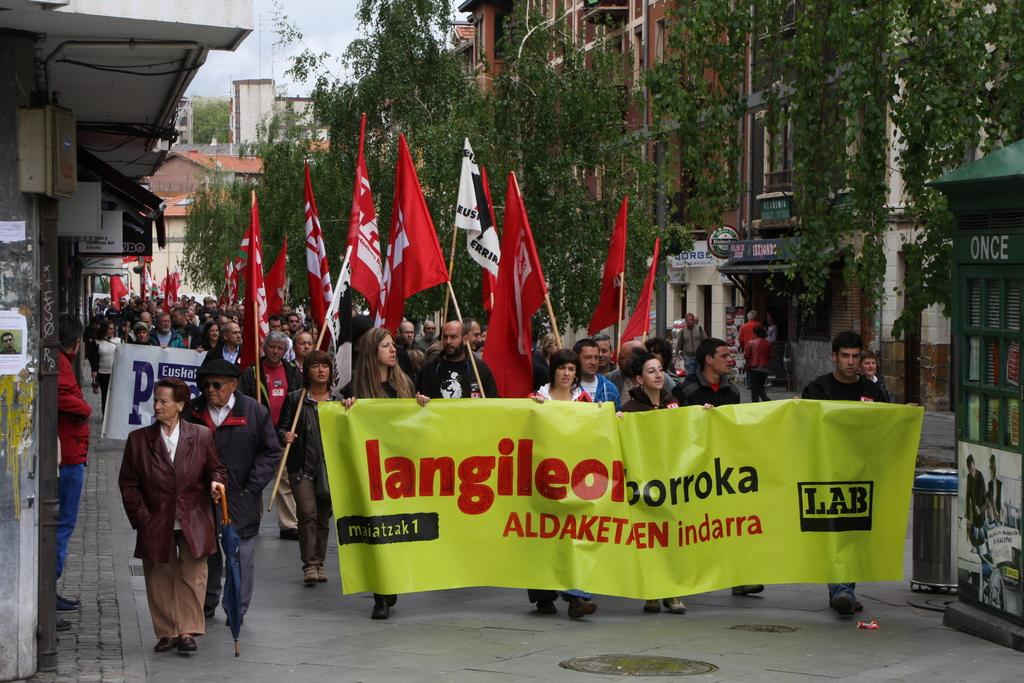What is happening in the image involving the group of people? The people in the image are holding flags and banners. What else can be seen in the image besides the group of people? There are buildings, trees, and the sky visible in the image. Can you describe the setting of the image? The image shows a group of people holding flags and banners in front of buildings, trees, and a visible sky. What type of thread is being used to cook the food in the image? There is no food or cooking activity present in the image, so there is no thread being used for cooking. 